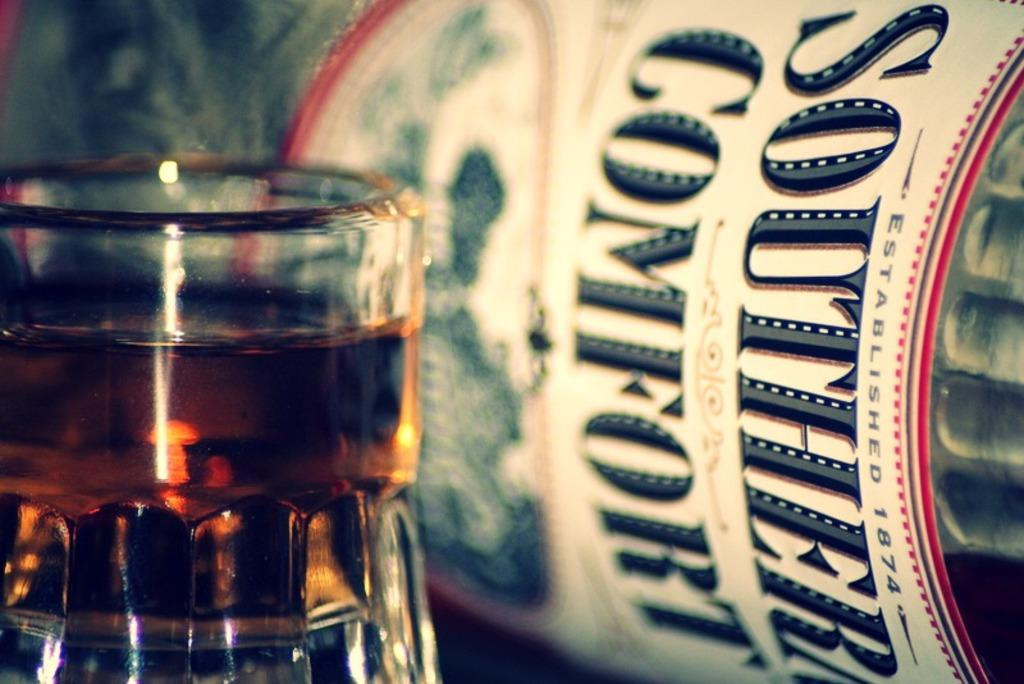<image>
Offer a succinct explanation of the picture presented. A glass of southern comfort whiskey with the bottle next to it 